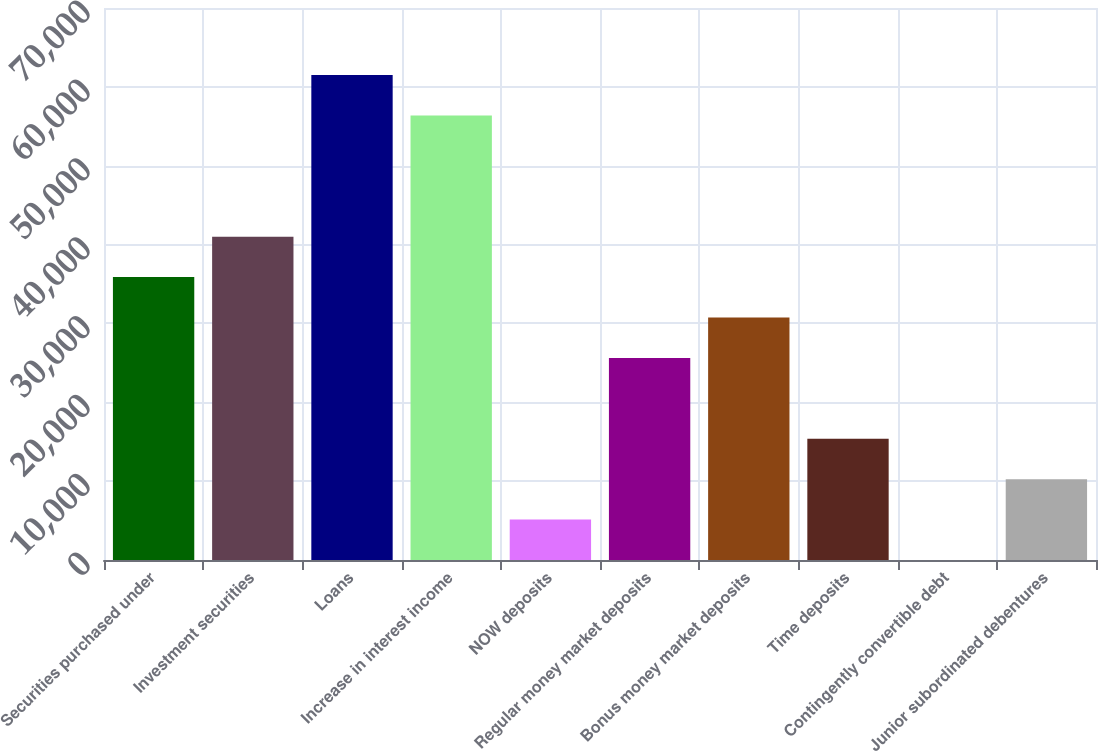Convert chart to OTSL. <chart><loc_0><loc_0><loc_500><loc_500><bar_chart><fcel>Securities purchased under<fcel>Investment securities<fcel>Loans<fcel>Increase in interest income<fcel>NOW deposits<fcel>Regular money market deposits<fcel>Bonus money market deposits<fcel>Time deposits<fcel>Contingently convertible debt<fcel>Junior subordinated debentures<nl><fcel>35875.8<fcel>41000.2<fcel>61497.8<fcel>56373.4<fcel>5129.4<fcel>25627<fcel>30751.4<fcel>15378.2<fcel>5<fcel>10253.8<nl></chart> 